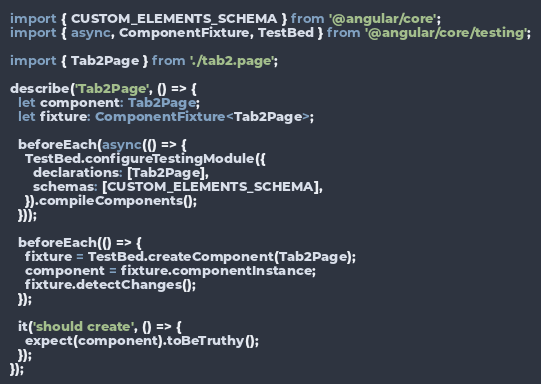Convert code to text. <code><loc_0><loc_0><loc_500><loc_500><_TypeScript_>import { CUSTOM_ELEMENTS_SCHEMA } from '@angular/core';
import { async, ComponentFixture, TestBed } from '@angular/core/testing';

import { Tab2Page } from './tab2.page';

describe('Tab2Page', () => {
  let component: Tab2Page;
  let fixture: ComponentFixture<Tab2Page>;

  beforeEach(async(() => {
    TestBed.configureTestingModule({
      declarations: [Tab2Page],
      schemas: [CUSTOM_ELEMENTS_SCHEMA],
    }).compileComponents();
  }));

  beforeEach(() => {
    fixture = TestBed.createComponent(Tab2Page);
    component = fixture.componentInstance;
    fixture.detectChanges();
  });

  it('should create', () => {
    expect(component).toBeTruthy();
  });
});
</code> 